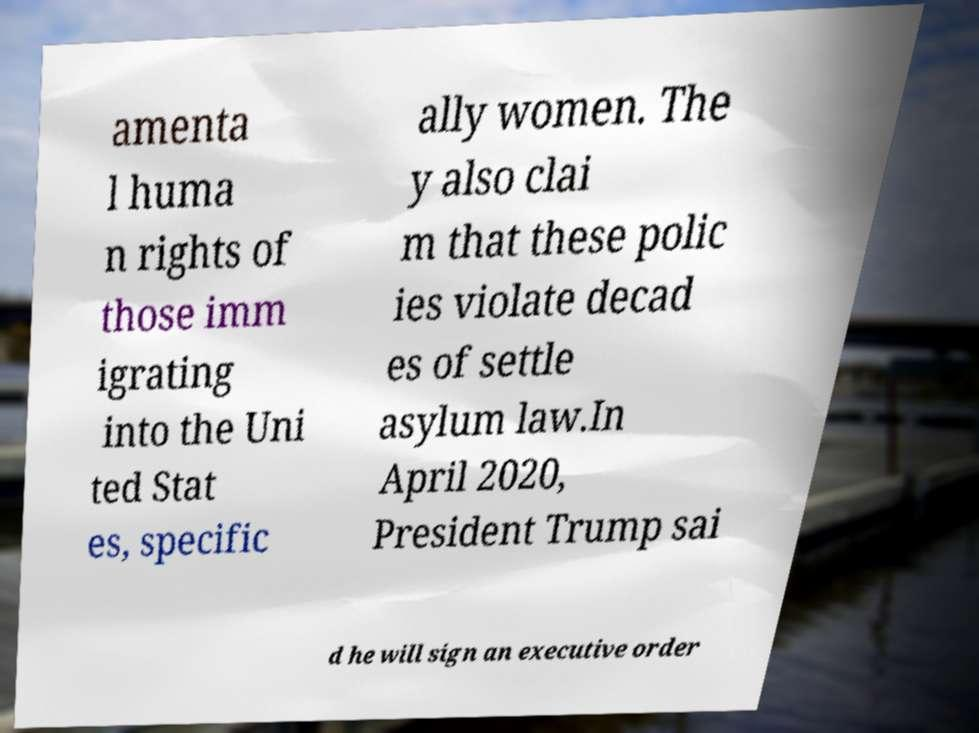Please identify and transcribe the text found in this image. amenta l huma n rights of those imm igrating into the Uni ted Stat es, specific ally women. The y also clai m that these polic ies violate decad es of settle asylum law.In April 2020, President Trump sai d he will sign an executive order 